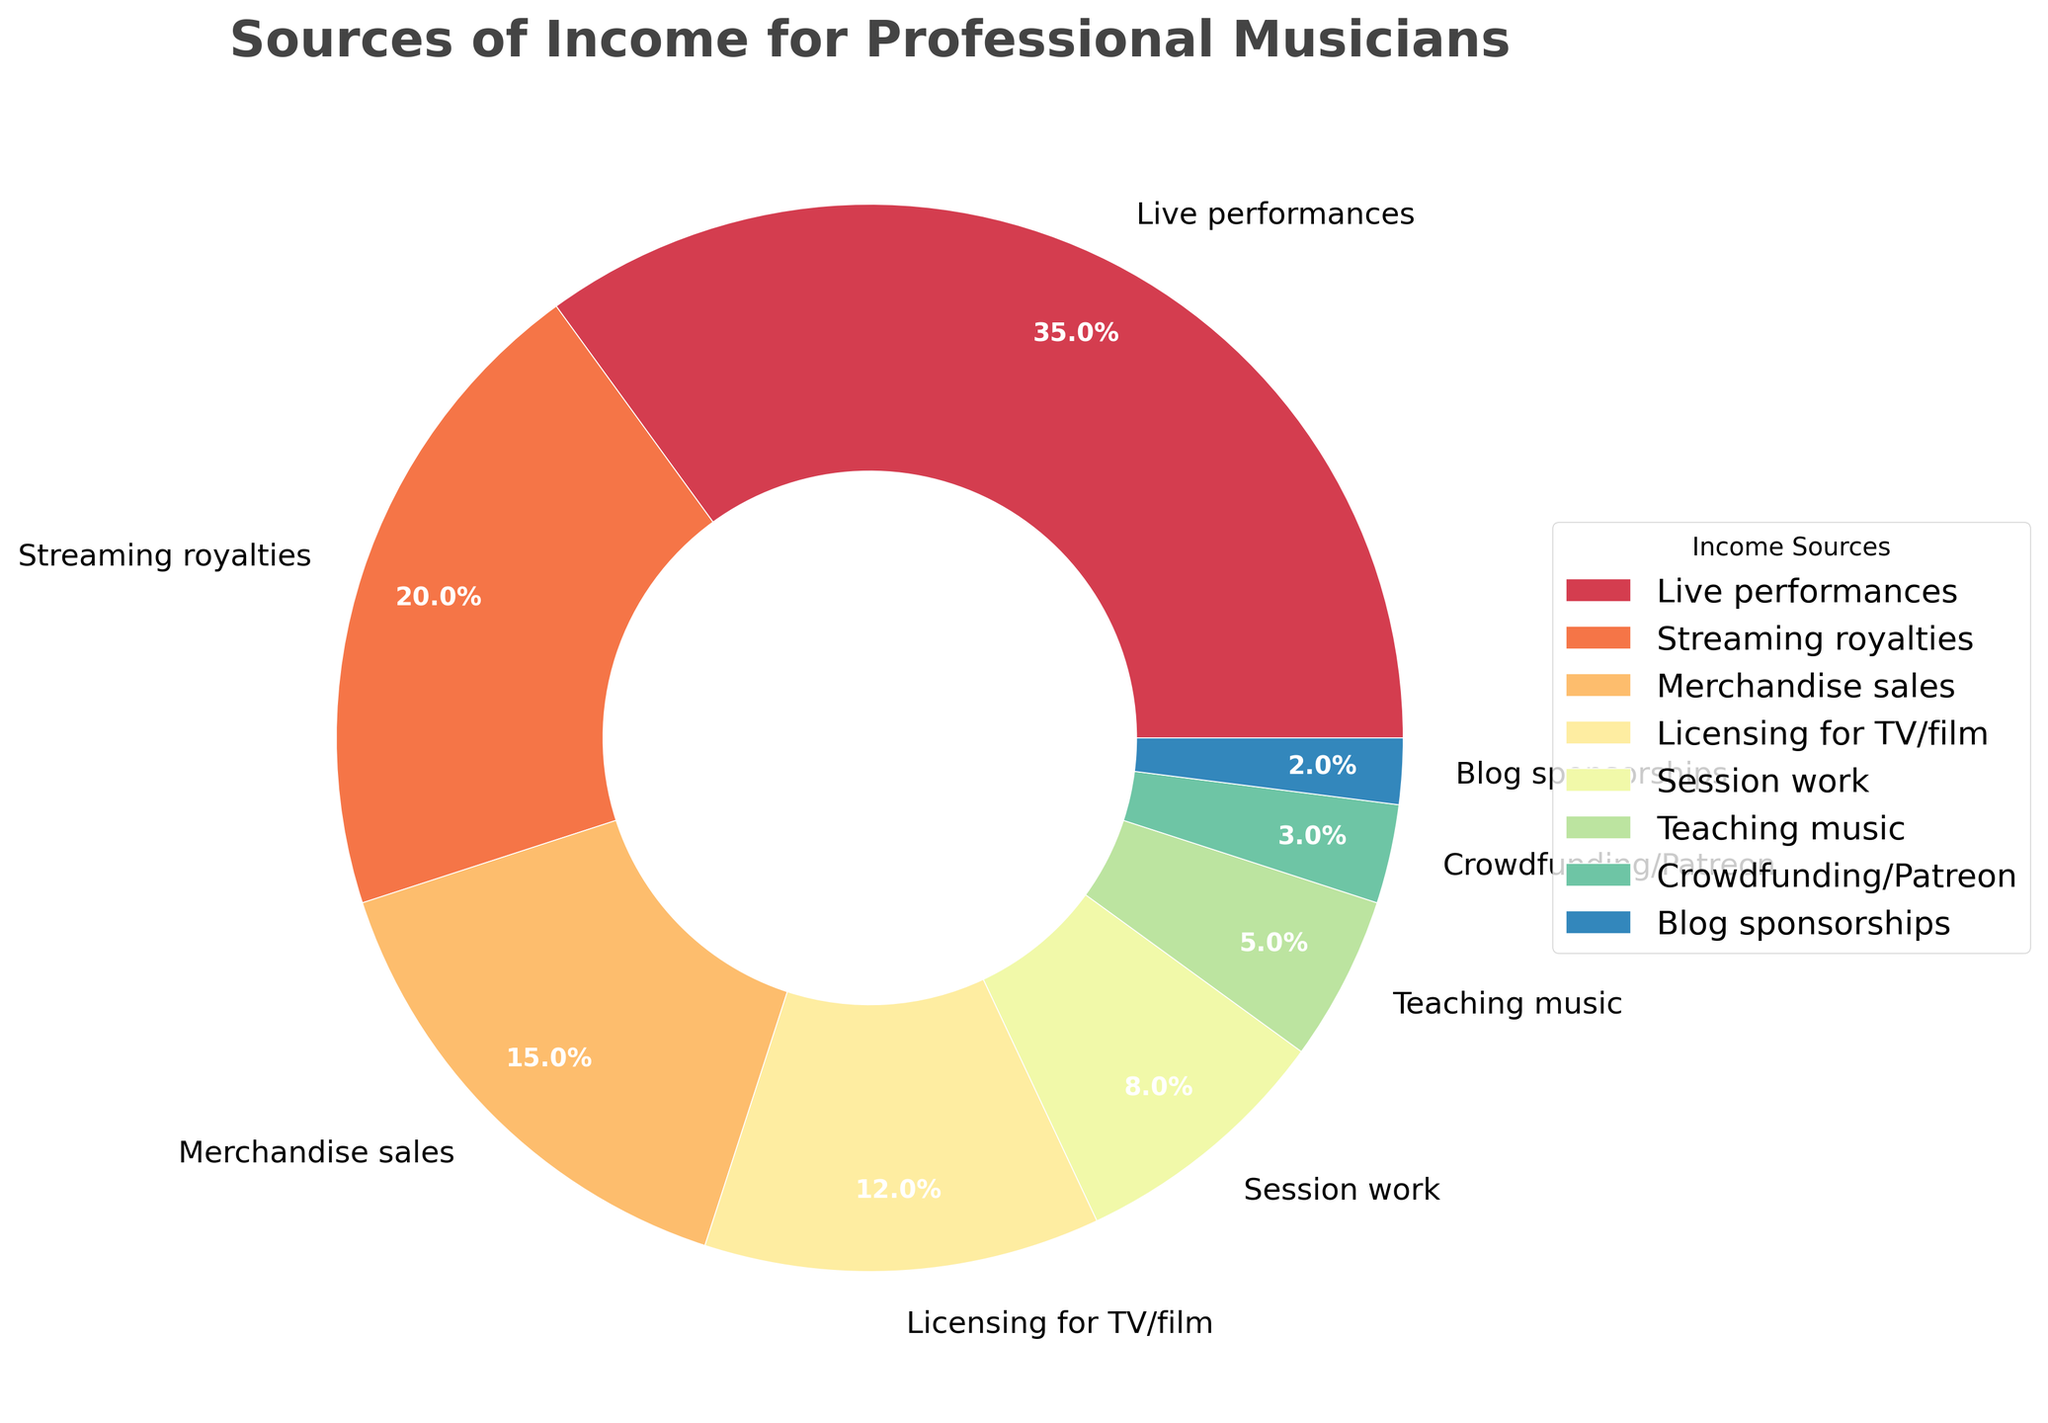What percentage of income comes from live performances? The legend and pie chart indicate that "Live performances" contribute to 35% of the total income.
Answer: 35% How does the percentage of income from streaming royalties compare to merchandise sales? The pie chart shows "Streaming royalties" at 20% and "Merchandise sales" at 15%. Therefore, streaming royalties contribute more to the total income than merchandise sales.
Answer: Streaming royalties contribute more What is the combined percentage of income from teaching music and crowdfunding/Patreon? The pie chart shows "Teaching music" at 5% and "Crowdfunding/Patreon" at 3%. Combined, they contribute 5% + 3% = 8% to the total income.
Answer: 8% Which source of income contributes the least, and what percentage is it? The pie chart indicates that "Blog sponsorships" contribute the least to the total income at 2%.
Answer: Blog sponsorships, 2% How much more does session work contribute to the income compared to blog sponsorships? The pie chart shows "Session work" at 8% and "Blog sponsorships" at 2%. The difference is 8% - 2% = 6%.
Answer: 6% List all income sources that contribute more than 10%. The pie chart shows "Live performances" (35%), "Streaming royalties" (20%), "Merchandise sales" (15%), and "Licensing for TV/film" (12%) contributing more than 10%.
Answer: Live performances, Streaming royalties, Merchandise sales, Licensing for TV/film What is the average percentage of income from live performances, streaming royalties, and merchandise sales? The pie chart shows percentages for "Live performances" (35%), "Streaming royalties" (20%), and "Merchandise sales" (15%). The average is calculated as (35 + 20 + 15) / 3 = 23.33%.
Answer: 23.33% Which three sources of income have the closest percentages, and what are they? The pie chart shows "Licensing for TV/film" at 12%, "Session work" at 8%, and "Teaching music" at 5%. These three sources have the percentages closest to each other.
Answer: Licensing for TV/film (12%), Session work (8%), Teaching music (5%) 